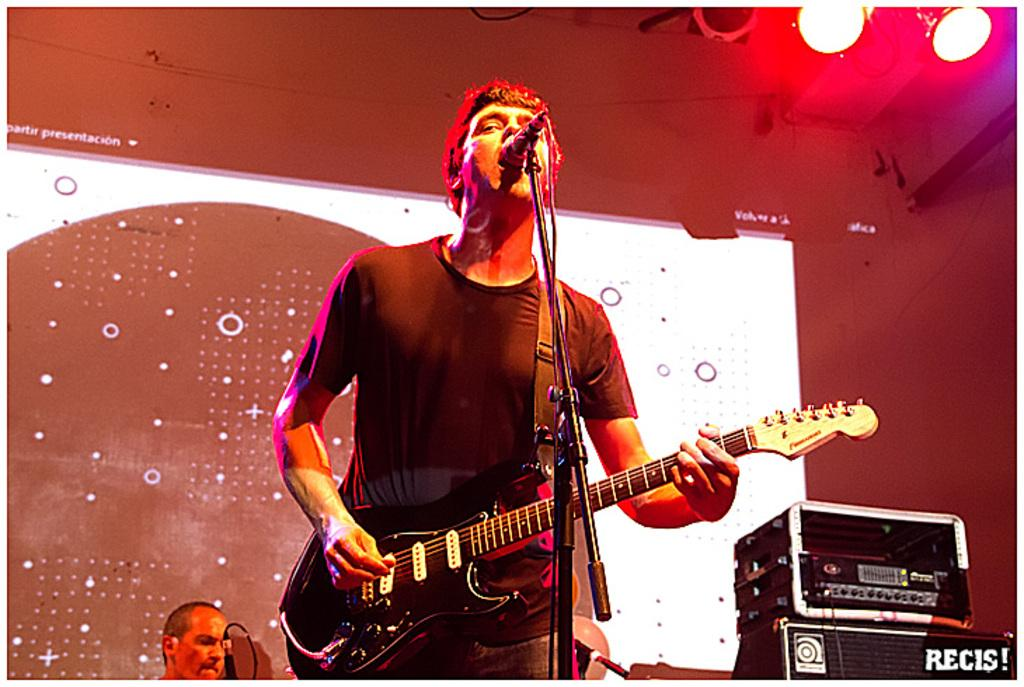What is the man in the image holding? The man is holding a guitar. What is the man doing in front of the microphone? The man is standing in front of a microphone, which suggests he might be singing or performing. Can you describe the background of the image? There is a person, a wall, and two lights in the background of the image. How many people are visible in the image? There are two people visible in the image: the man with the guitar and the person in the background. Can you see the seashore in the image? No, the seashore is not present in the image. 